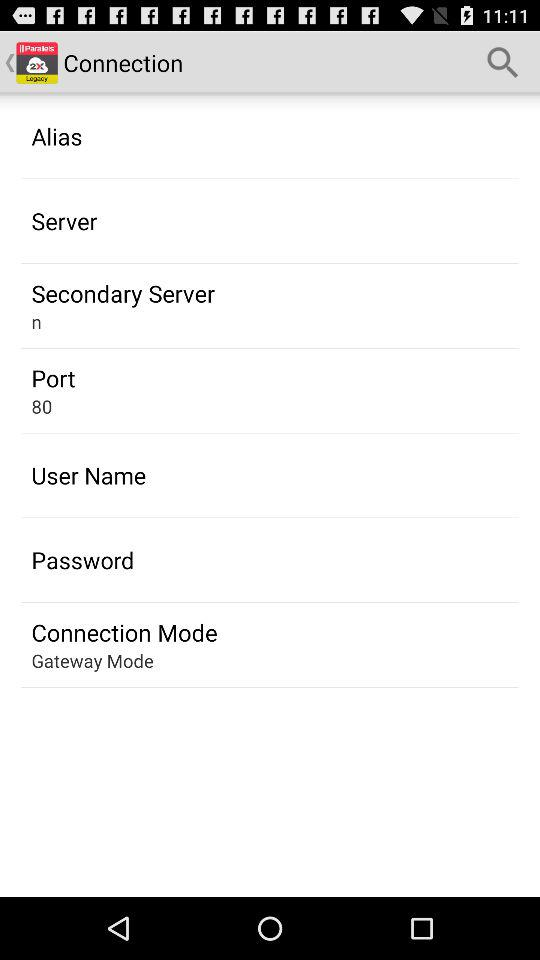What is the connection mode? The mode is "Gateway Mode". 